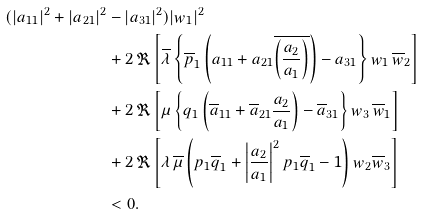Convert formula to latex. <formula><loc_0><loc_0><loc_500><loc_500>( | a _ { 1 1 } | ^ { 2 } + | a _ { 2 1 } | ^ { 2 } & - | a _ { 3 1 } | ^ { 2 } ) | w _ { 1 } | ^ { 2 } \\ & + 2 \, { \Re } \left [ \overline { \lambda } \left \{ \overline { p } _ { 1 } \left ( a _ { 1 1 } + a _ { 2 1 } \overline { \left ( \frac { a _ { 2 } } { a _ { 1 } } \right ) } \right ) - a _ { 3 1 } \right \} w _ { 1 } \, \overline { w } _ { 2 } \right ] \\ & + 2 \, { \Re } \left [ \mu \left \{ q _ { 1 } \left ( \overline { a } _ { 1 1 } + \overline { a } _ { 2 1 } \frac { a _ { 2 } } { a _ { 1 } } \right ) - \overline { a } _ { 3 1 } \right \} w _ { 3 } \, \overline { w } _ { 1 } \right ] \\ & + 2 \, { \Re } \left [ \lambda \, \overline { \mu } \left ( p _ { 1 } \overline { q } _ { 1 } + \left | \frac { a _ { 2 } } { a _ { 1 } } \right | ^ { 2 } p _ { 1 } \overline { q } _ { 1 } - 1 \right ) w _ { 2 } \overline { w } _ { 3 } \right ] \\ & < 0 .</formula> 